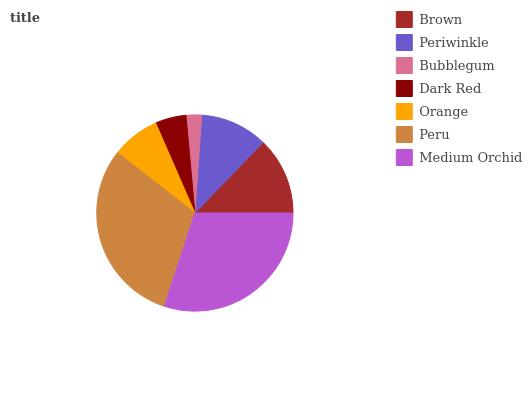Is Bubblegum the minimum?
Answer yes or no. Yes. Is Peru the maximum?
Answer yes or no. Yes. Is Periwinkle the minimum?
Answer yes or no. No. Is Periwinkle the maximum?
Answer yes or no. No. Is Brown greater than Periwinkle?
Answer yes or no. Yes. Is Periwinkle less than Brown?
Answer yes or no. Yes. Is Periwinkle greater than Brown?
Answer yes or no. No. Is Brown less than Periwinkle?
Answer yes or no. No. Is Periwinkle the high median?
Answer yes or no. Yes. Is Periwinkle the low median?
Answer yes or no. Yes. Is Orange the high median?
Answer yes or no. No. Is Orange the low median?
Answer yes or no. No. 